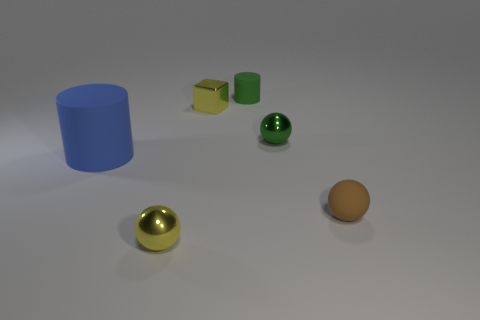There is a rubber thing that is in front of the big blue rubber cylinder; what color is it?
Ensure brevity in your answer.  Brown. What number of other objects are the same size as the green rubber object?
Keep it short and to the point. 4. What is the size of the thing that is right of the small block and behind the green metal ball?
Offer a very short reply. Small. Is the color of the large cylinder the same as the small metal sphere that is behind the blue rubber thing?
Keep it short and to the point. No. Is there a blue rubber object that has the same shape as the small green matte thing?
Your answer should be compact. Yes. How many objects are tiny yellow balls or yellow things left of the small yellow shiny block?
Provide a short and direct response. 1. How many other objects are the same material as the big thing?
Give a very brief answer. 2. What number of things are large cyan matte cylinders or green metal objects?
Give a very brief answer. 1. Is the number of tiny brown rubber things to the left of the small yellow block greater than the number of small matte spheres left of the rubber ball?
Your answer should be compact. No. There is a object in front of the brown rubber ball; is its color the same as the cylinder behind the big blue rubber cylinder?
Your answer should be very brief. No. 